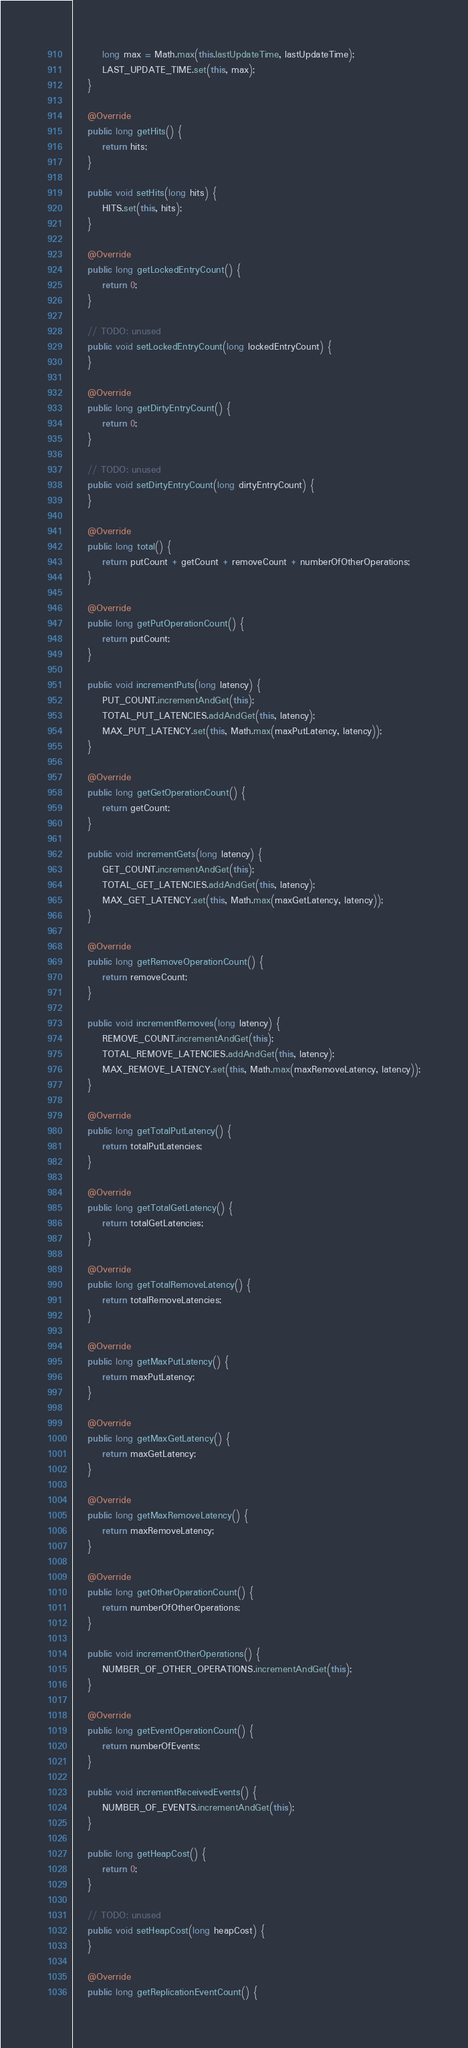<code> <loc_0><loc_0><loc_500><loc_500><_Java_>        long max = Math.max(this.lastUpdateTime, lastUpdateTime);
        LAST_UPDATE_TIME.set(this, max);
    }

    @Override
    public long getHits() {
        return hits;
    }

    public void setHits(long hits) {
        HITS.set(this, hits);
    }

    @Override
    public long getLockedEntryCount() {
        return 0;
    }

    // TODO: unused
    public void setLockedEntryCount(long lockedEntryCount) {
    }

    @Override
    public long getDirtyEntryCount() {
        return 0;
    }

    // TODO: unused
    public void setDirtyEntryCount(long dirtyEntryCount) {
    }

    @Override
    public long total() {
        return putCount + getCount + removeCount + numberOfOtherOperations;
    }

    @Override
    public long getPutOperationCount() {
        return putCount;
    }

    public void incrementPuts(long latency) {
        PUT_COUNT.incrementAndGet(this);
        TOTAL_PUT_LATENCIES.addAndGet(this, latency);
        MAX_PUT_LATENCY.set(this, Math.max(maxPutLatency, latency));
    }

    @Override
    public long getGetOperationCount() {
        return getCount;
    }

    public void incrementGets(long latency) {
        GET_COUNT.incrementAndGet(this);
        TOTAL_GET_LATENCIES.addAndGet(this, latency);
        MAX_GET_LATENCY.set(this, Math.max(maxGetLatency, latency));
    }

    @Override
    public long getRemoveOperationCount() {
        return removeCount;
    }

    public void incrementRemoves(long latency) {
        REMOVE_COUNT.incrementAndGet(this);
        TOTAL_REMOVE_LATENCIES.addAndGet(this, latency);
        MAX_REMOVE_LATENCY.set(this, Math.max(maxRemoveLatency, latency));
    }

    @Override
    public long getTotalPutLatency() {
        return totalPutLatencies;
    }

    @Override
    public long getTotalGetLatency() {
        return totalGetLatencies;
    }

    @Override
    public long getTotalRemoveLatency() {
        return totalRemoveLatencies;
    }

    @Override
    public long getMaxPutLatency() {
        return maxPutLatency;
    }

    @Override
    public long getMaxGetLatency() {
        return maxGetLatency;
    }

    @Override
    public long getMaxRemoveLatency() {
        return maxRemoveLatency;
    }

    @Override
    public long getOtherOperationCount() {
        return numberOfOtherOperations;
    }

    public void incrementOtherOperations() {
        NUMBER_OF_OTHER_OPERATIONS.incrementAndGet(this);
    }

    @Override
    public long getEventOperationCount() {
        return numberOfEvents;
    }

    public void incrementReceivedEvents() {
        NUMBER_OF_EVENTS.incrementAndGet(this);
    }

    public long getHeapCost() {
        return 0;
    }

    // TODO: unused
    public void setHeapCost(long heapCost) {
    }

    @Override
    public long getReplicationEventCount() {</code> 